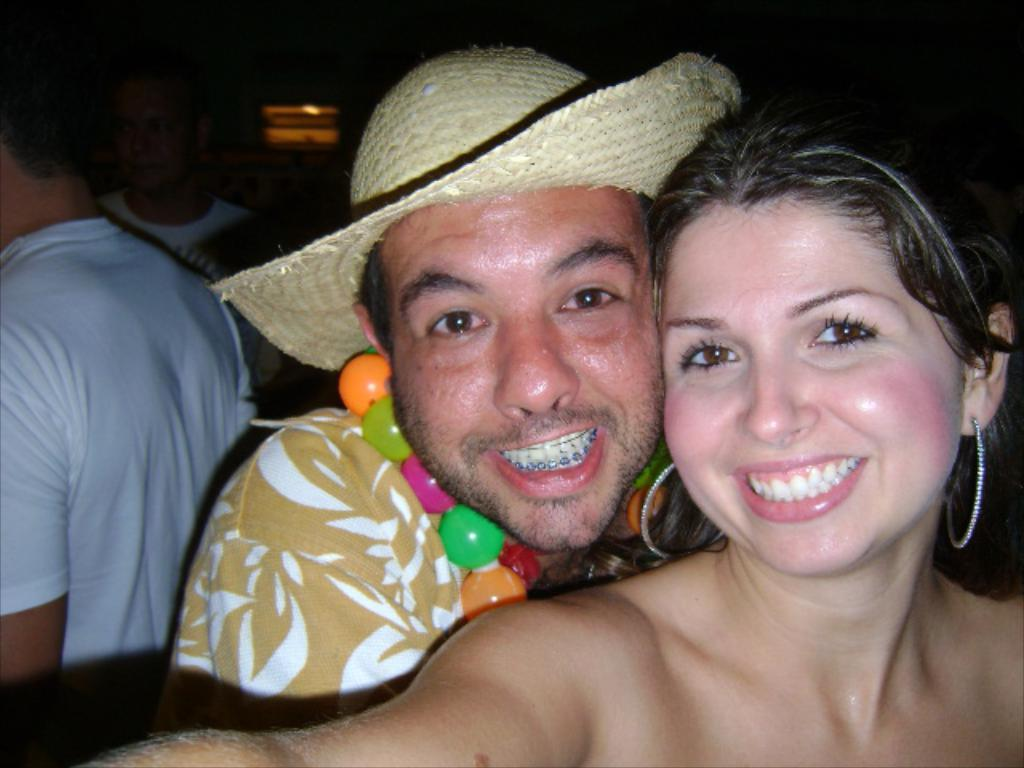How many people are in the image? There are two persons in the image. What colors are present in the shirt of the person in front? The person in front is wearing a yellow and white color shirt. What color is the shirt of the person at the left? The person at the left is wearing a white color shirt. What is the color of the background in the image? The background of the image is black. What type of jail can be seen in the background of the image? There is no jail present in the image; the background is black. Can you tell me how many porters are visible in the image? There are no porters present in the image. 